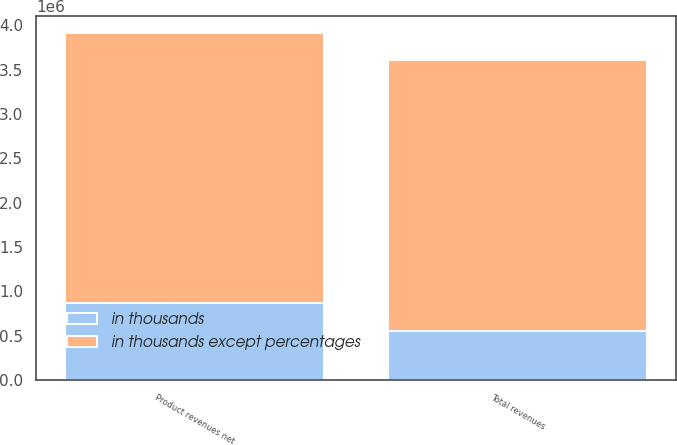Convert chart. <chart><loc_0><loc_0><loc_500><loc_500><stacked_bar_chart><ecel><fcel>Product revenues net<fcel>Total revenues<nl><fcel>in thousands except percentages<fcel>3.03832e+06<fcel>3.0476e+06<nl><fcel>in thousands<fcel>872845<fcel>558945<nl></chart> 